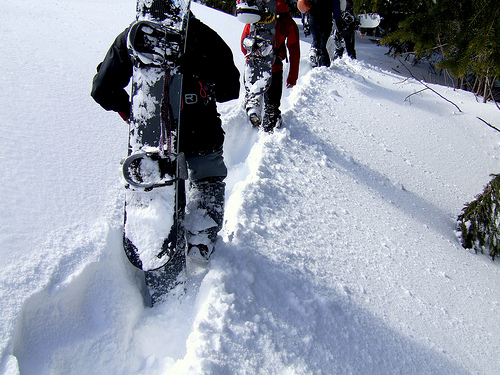<image>
Is there a boot under the snow? Yes. The boot is positioned underneath the snow, with the snow above it in the vertical space. 